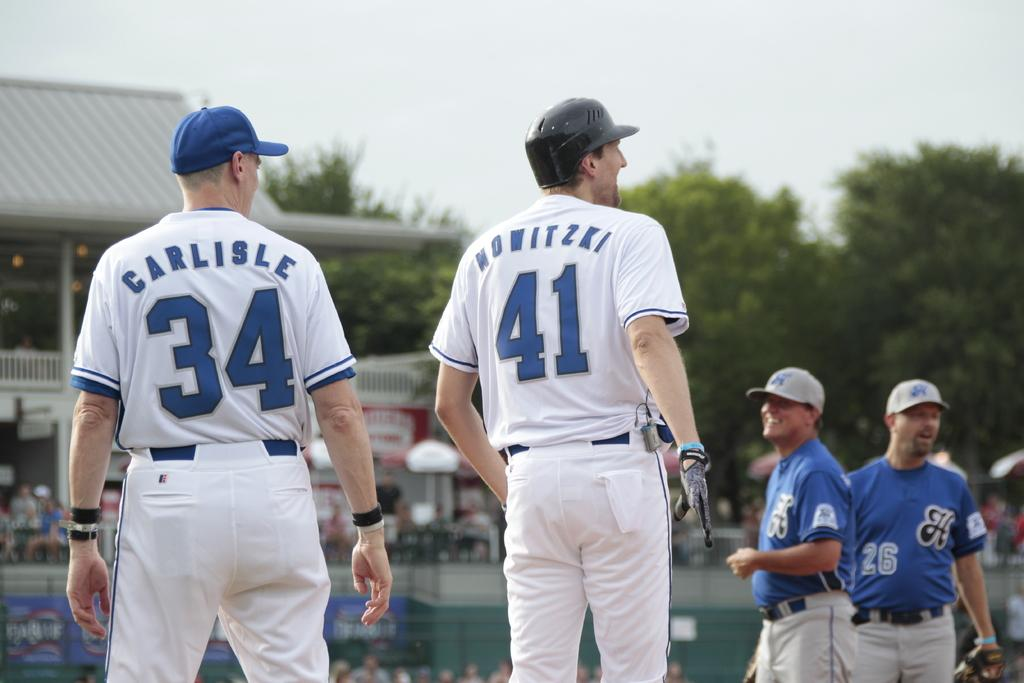<image>
Provide a brief description of the given image. Carlisle, who is number 34, is the player on the left. 